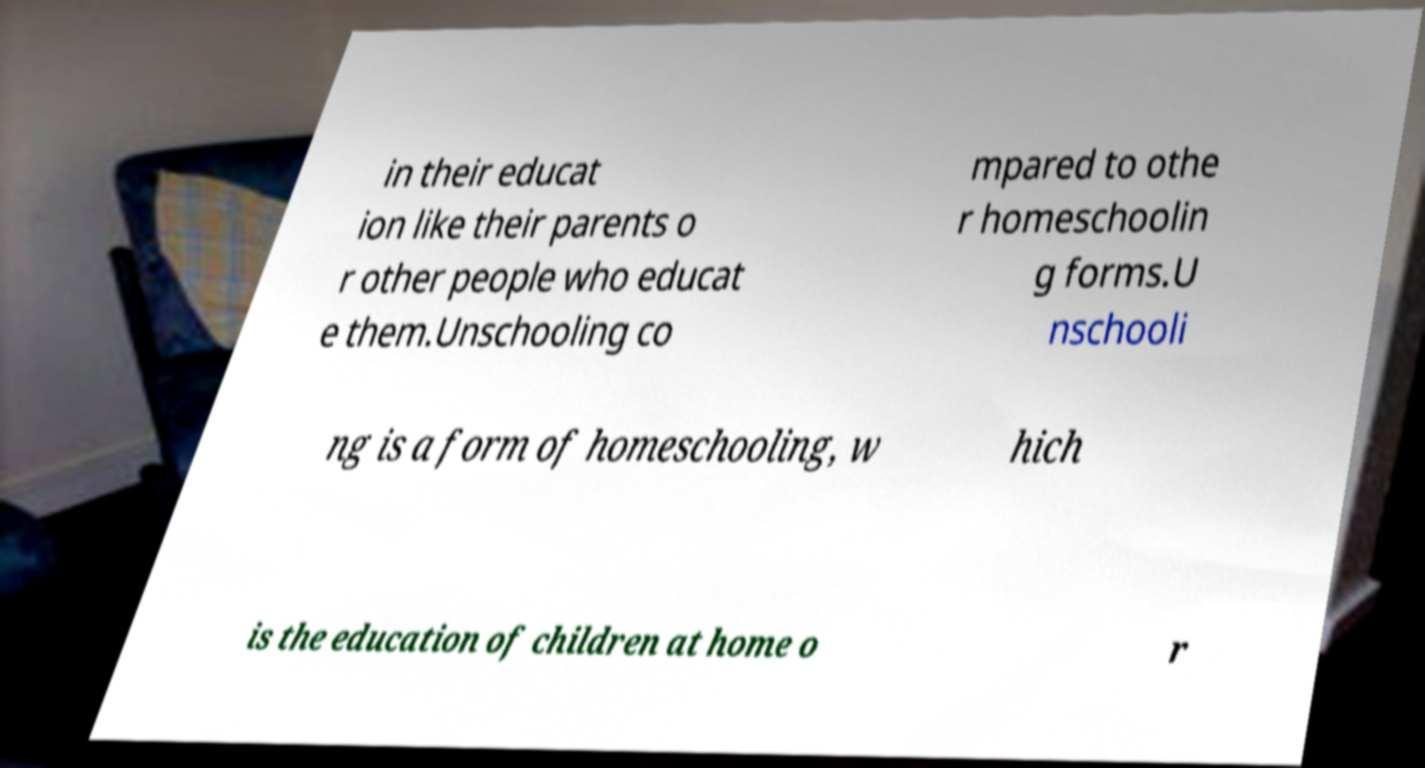Can you accurately transcribe the text from the provided image for me? in their educat ion like their parents o r other people who educat e them.Unschooling co mpared to othe r homeschoolin g forms.U nschooli ng is a form of homeschooling, w hich is the education of children at home o r 